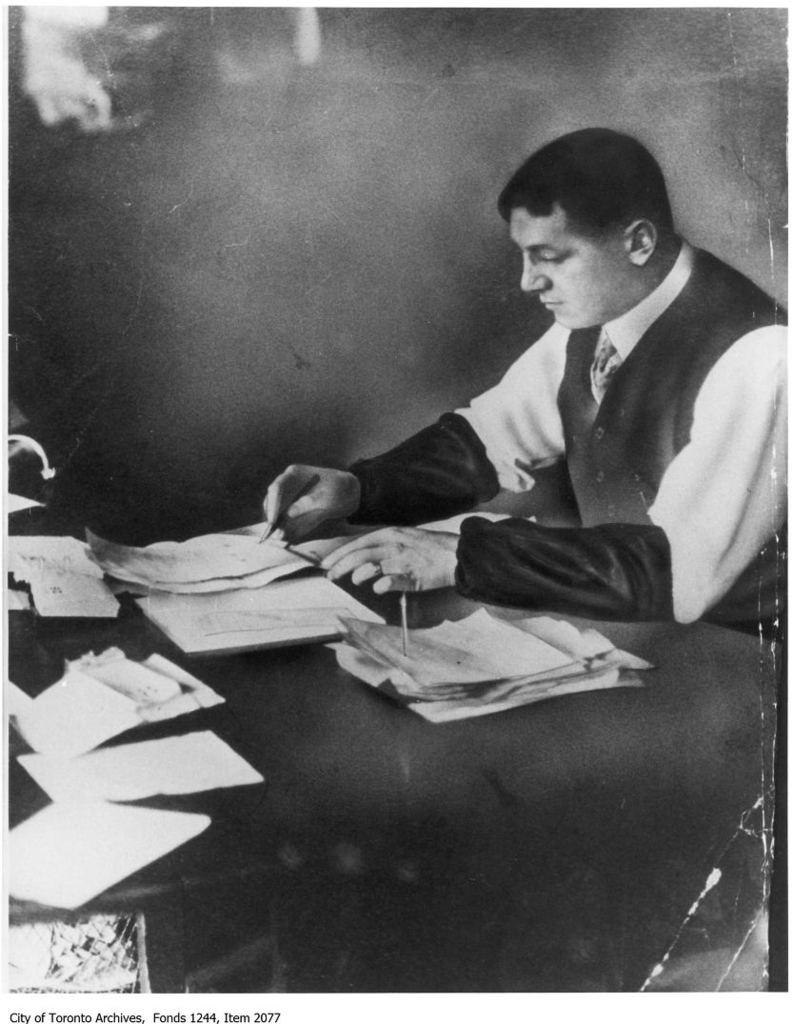What is the color scheme of the image? The image is black and white. Who is present in the image? There is a man in the image. What is the man doing in the image? The man is writing on a paper. What can be seen on the table in the image? There is a table in the image, and there are papers on the table. How would you describe the lighting in the image? The background of the image is dark. What type of linen is visible on the table in the image? There is no linen visible on the table in the image; only papers are present. What fictional character is the man writing about in the image? The image does not provide any information about the content of the man's writing, so it cannot be determined if he is writing about a fictional character. 